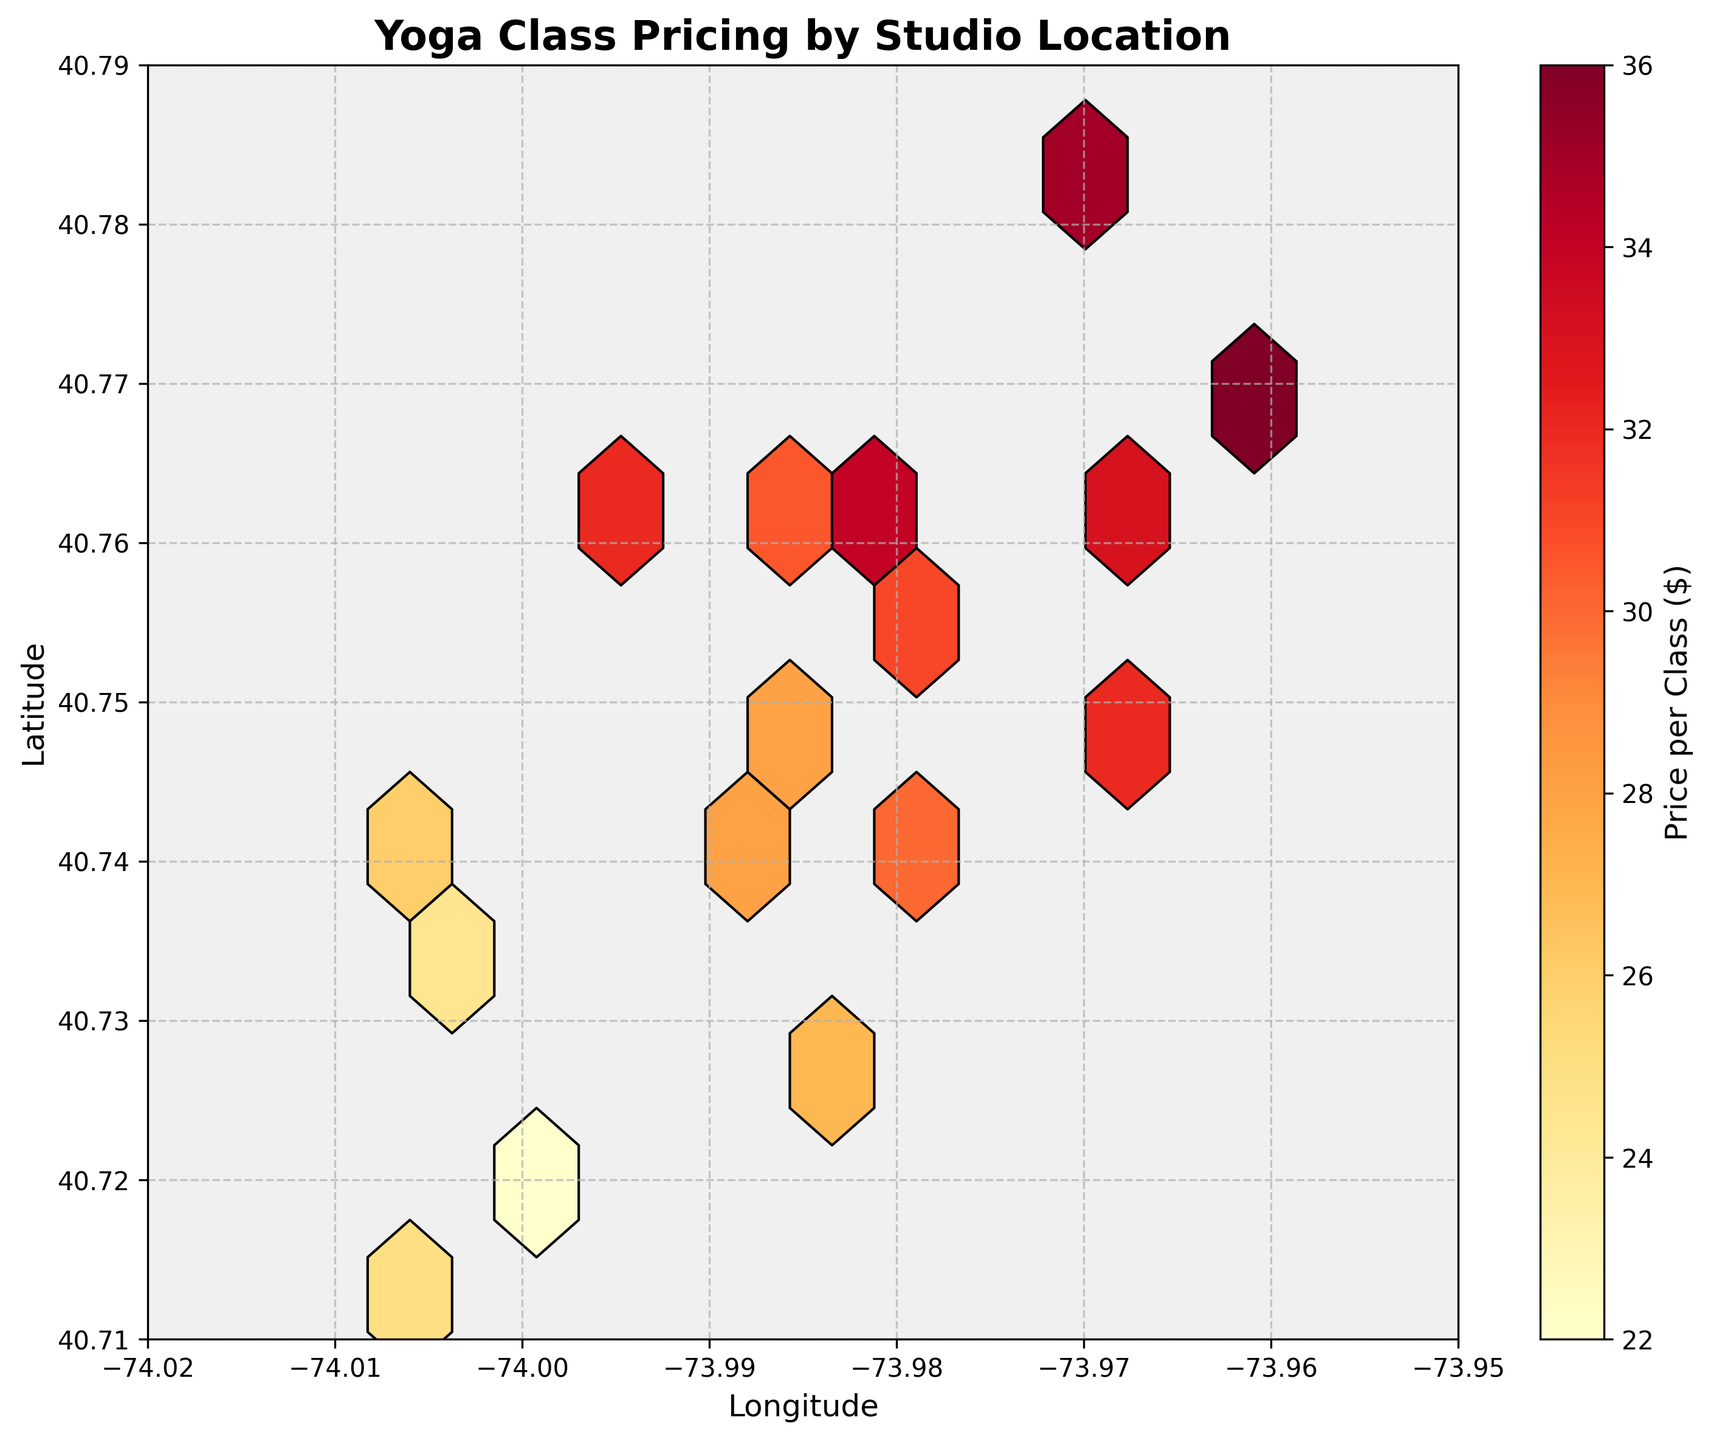What's the title of the figure? The title is written at the top of the figure in bold and larger font. It provides a summary of what the plot represents.
Answer: Yoga Class Pricing by Studio Location What do the colors in the hexagons represent? The color gradient in the hexagons indicates the price per class, with a color bar on the side explaining the range of prices.
Answer: Price per class ($) What is the range of the longitude and latitude displayed in the plot? The axis labels and ticks provide the range. Longitude ranges from -74.02 to -73.95, and latitude ranges from 40.71 to 40.79.
Answer: Longitude: -74.02 to -73.95, Latitude: 40.71 to 40.79 Which area appears to have the highest average price per class? The area with the darkest hexagons represents the highest prices. By locating the darkest hexagons, you can identify the area with the highest average price.
Answer: Around (40.7694, -73.9609) What is the average price per class in the hexagons with the lowest prices? Locate the lightest-colored hexagons. The color bar indicates the pricing range for these areas, and the average price can be inferred.
Answer: Around $22-$25 Is there any noticeable pattern in the distribution of yoga class prices based on the location? By observing the plot, look for clusters or patterns in color distribution. The denser, darker clusters indicate higher prices, often in specific regions.
Answer: Higher prices tend to cluster in specific areas Which latitude has a greater concentration of high-priced yoga classes, 40.73 or 40.76? Compare the color density of hexagons at these latitudes. The latitude with more dark-colored hexagons has a greater concentration of high-priced classes.
Answer: 40.76 What is the price range for the central urban areas with hexagons centered around (40.7484, -73.9857)? Look at the color of hexagons around this coordinate and refer to the color bar to determine the price range.
Answer: $28-$32 Are there any outliers in terms of yoga class prices? Outliers can be identified if there are hexagons with an extremely different color compared to surrounding hexagons, indicating unusual prices.
Answer: There are no significant outliers Which urban area's studios potentially offer the most affordable classes, based on the plot? Locate the lightest hexagons indicating the lowest prices. The geographic coordinates of these hexagons reveal the area.
Answer: Around (40.7185, -73.9999) 